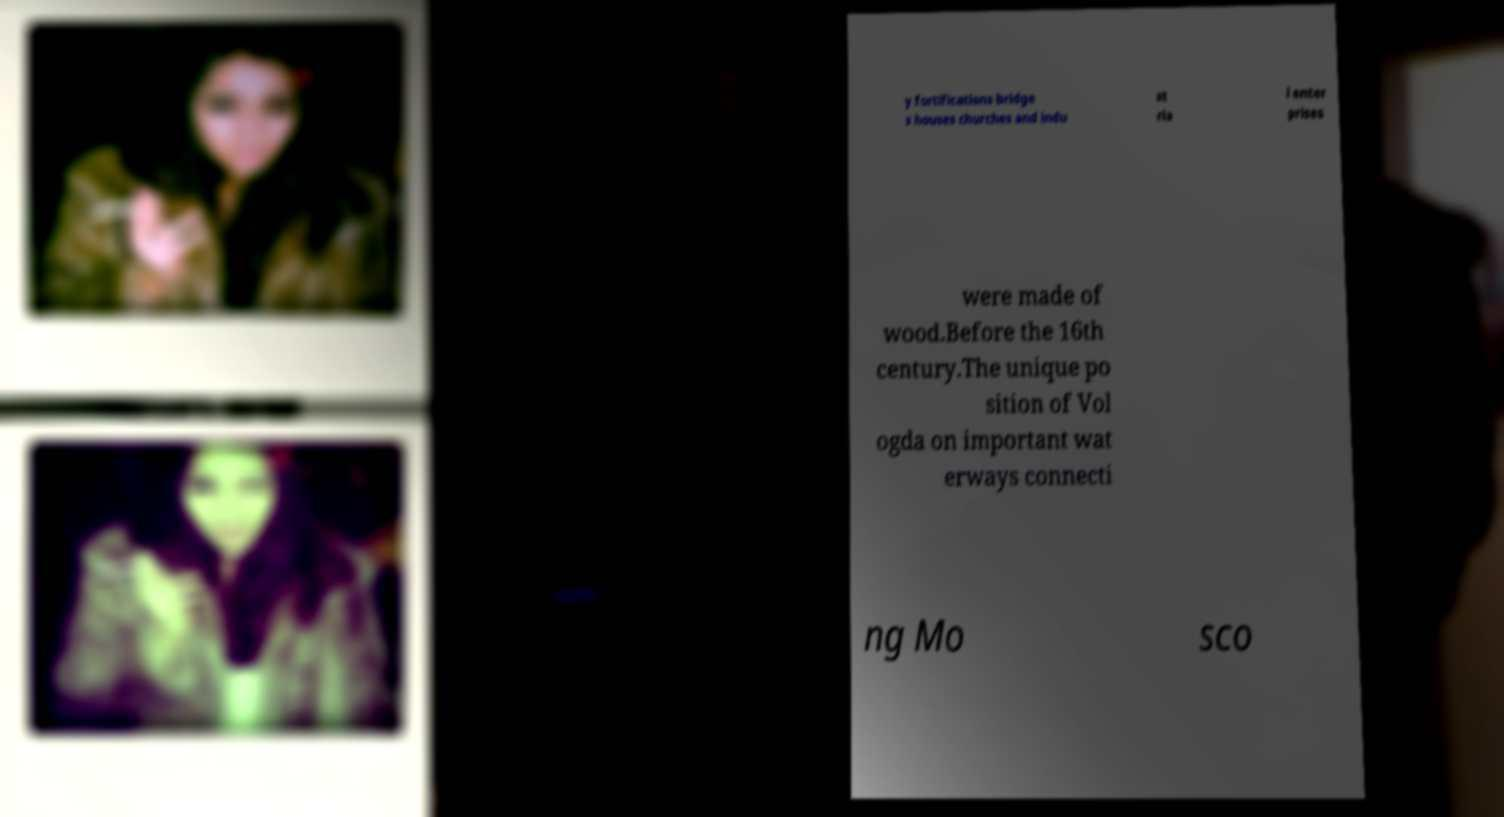I need the written content from this picture converted into text. Can you do that? y fortifications bridge s houses churches and indu st ria l enter prises were made of wood.Before the 16th century.The unique po sition of Vol ogda on important wat erways connecti ng Mo sco 